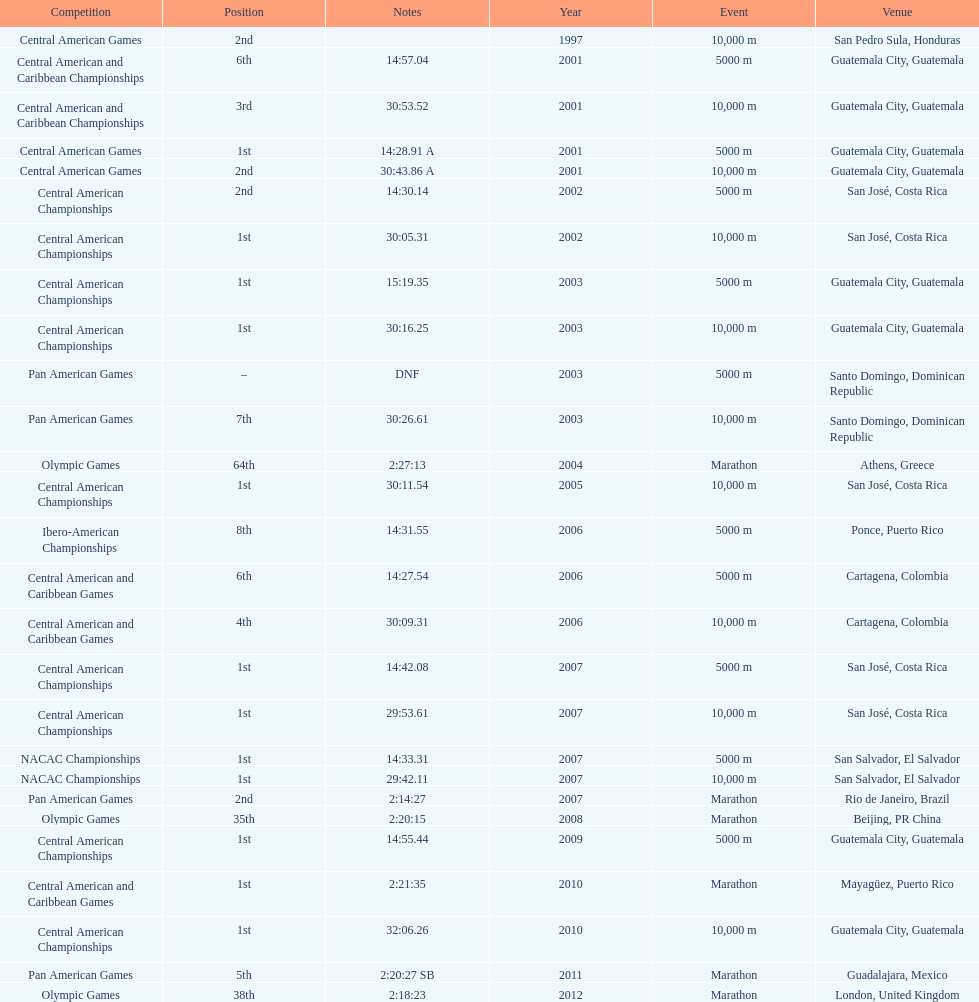How many times has this athlete not finished in a competition? 1. 